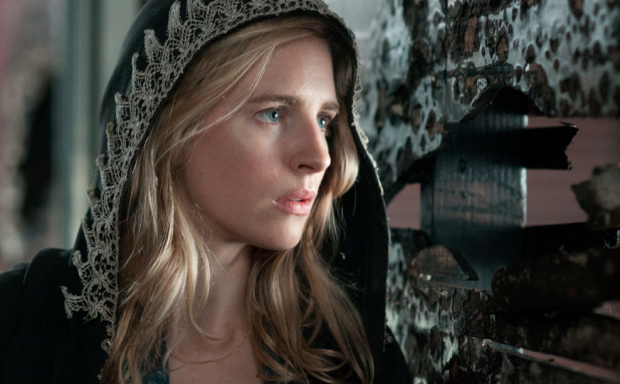What story could be unfolding in this image? The image hints at a story brimming with tension and mystery. The character, cloaked in dark attire with an expression full of concern, might be a secretive figure in a dystopian world, navigating through perilous circumstances. She could be on a mission to uncover hidden truths, find a missing person, or escape from oppressive forces. The peeling posters and stark setting suggest a world where society has crumbled, adding layers of intrigue and urgency to her journey. Imagine this character finds a secret map. What happens next? Upon discovering the secret map hidden behind the peeling posters, the character's eyes widen with realization. The map reveals forgotten pathways and hidden locations that could be crucial for her mission. With renewed determination, she sets out on a perilous journey, facing various obstacles and adversaries. Along the way, she meets allies who aid her in decoding the map's cryptic clues, leading her to a significant discovery that could change the course of her world. The adventure is fraught with danger, but her resolve strengthens with every step as she inches closer to uncovering a life-altering secret. If the image were part of a dream, what surreal elements might be added? In a dream version of this scene, the atmosphere might be imbued with ethereal and fantastical elements. The peeling posters on the wall could reveal hidden, glowing symbols that change shape and color, guiding the character through an ever-shifting labyrinth. Her cloak might transform into a protective shield that adapts to her thoughts and emotions. The backdrop could morph into a surreal landscape with floating islands and bizarre, otherworldly creatures that communicate in whispers. Time might fluctuate, speeding up and slowing down unpredictably, adding an extra layer of disorientation and wonder to her journey. 